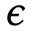<formula> <loc_0><loc_0><loc_500><loc_500>\epsilon</formula> 